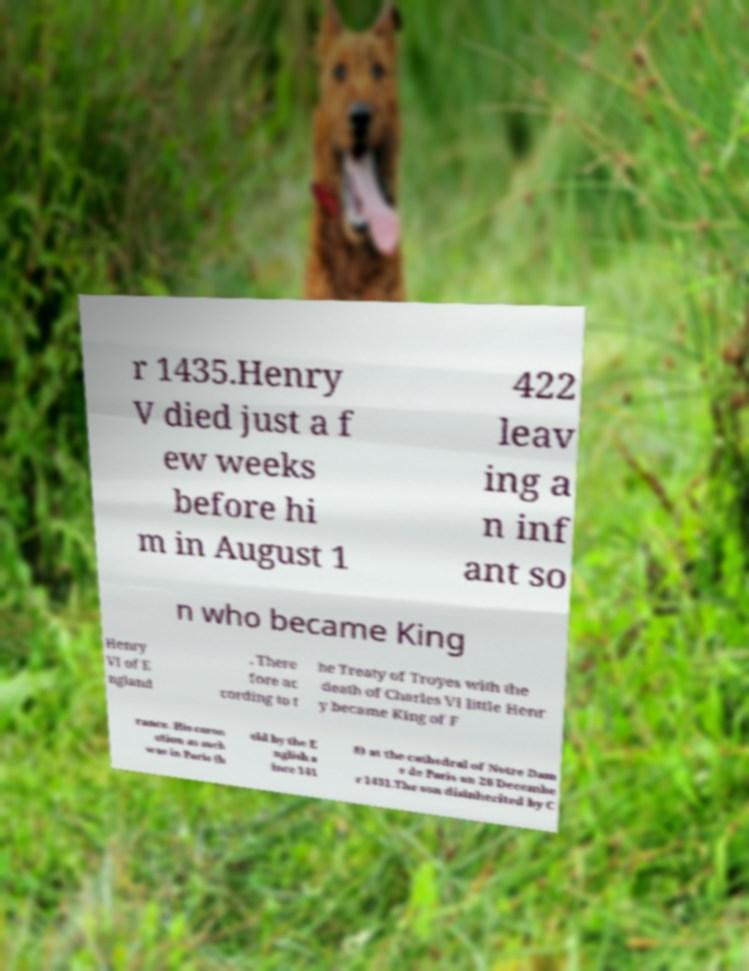Could you assist in decoding the text presented in this image and type it out clearly? r 1435.Henry V died just a f ew weeks before hi m in August 1 422 leav ing a n inf ant so n who became King Henry VI of E ngland . There fore ac cording to t he Treaty of Troyes with the death of Charles VI little Henr y became King of F rance. His coron ation as such was in Paris (h eld by the E nglish s ince 141 8) at the cathedral of Notre Dam e de Paris on 26 Decembe r 1431.The son disinherited by C 